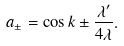Convert formula to latex. <formula><loc_0><loc_0><loc_500><loc_500>a _ { \pm } = \cos { k } \pm \frac { \lambda ^ { \prime } } { 4 \lambda } .</formula> 